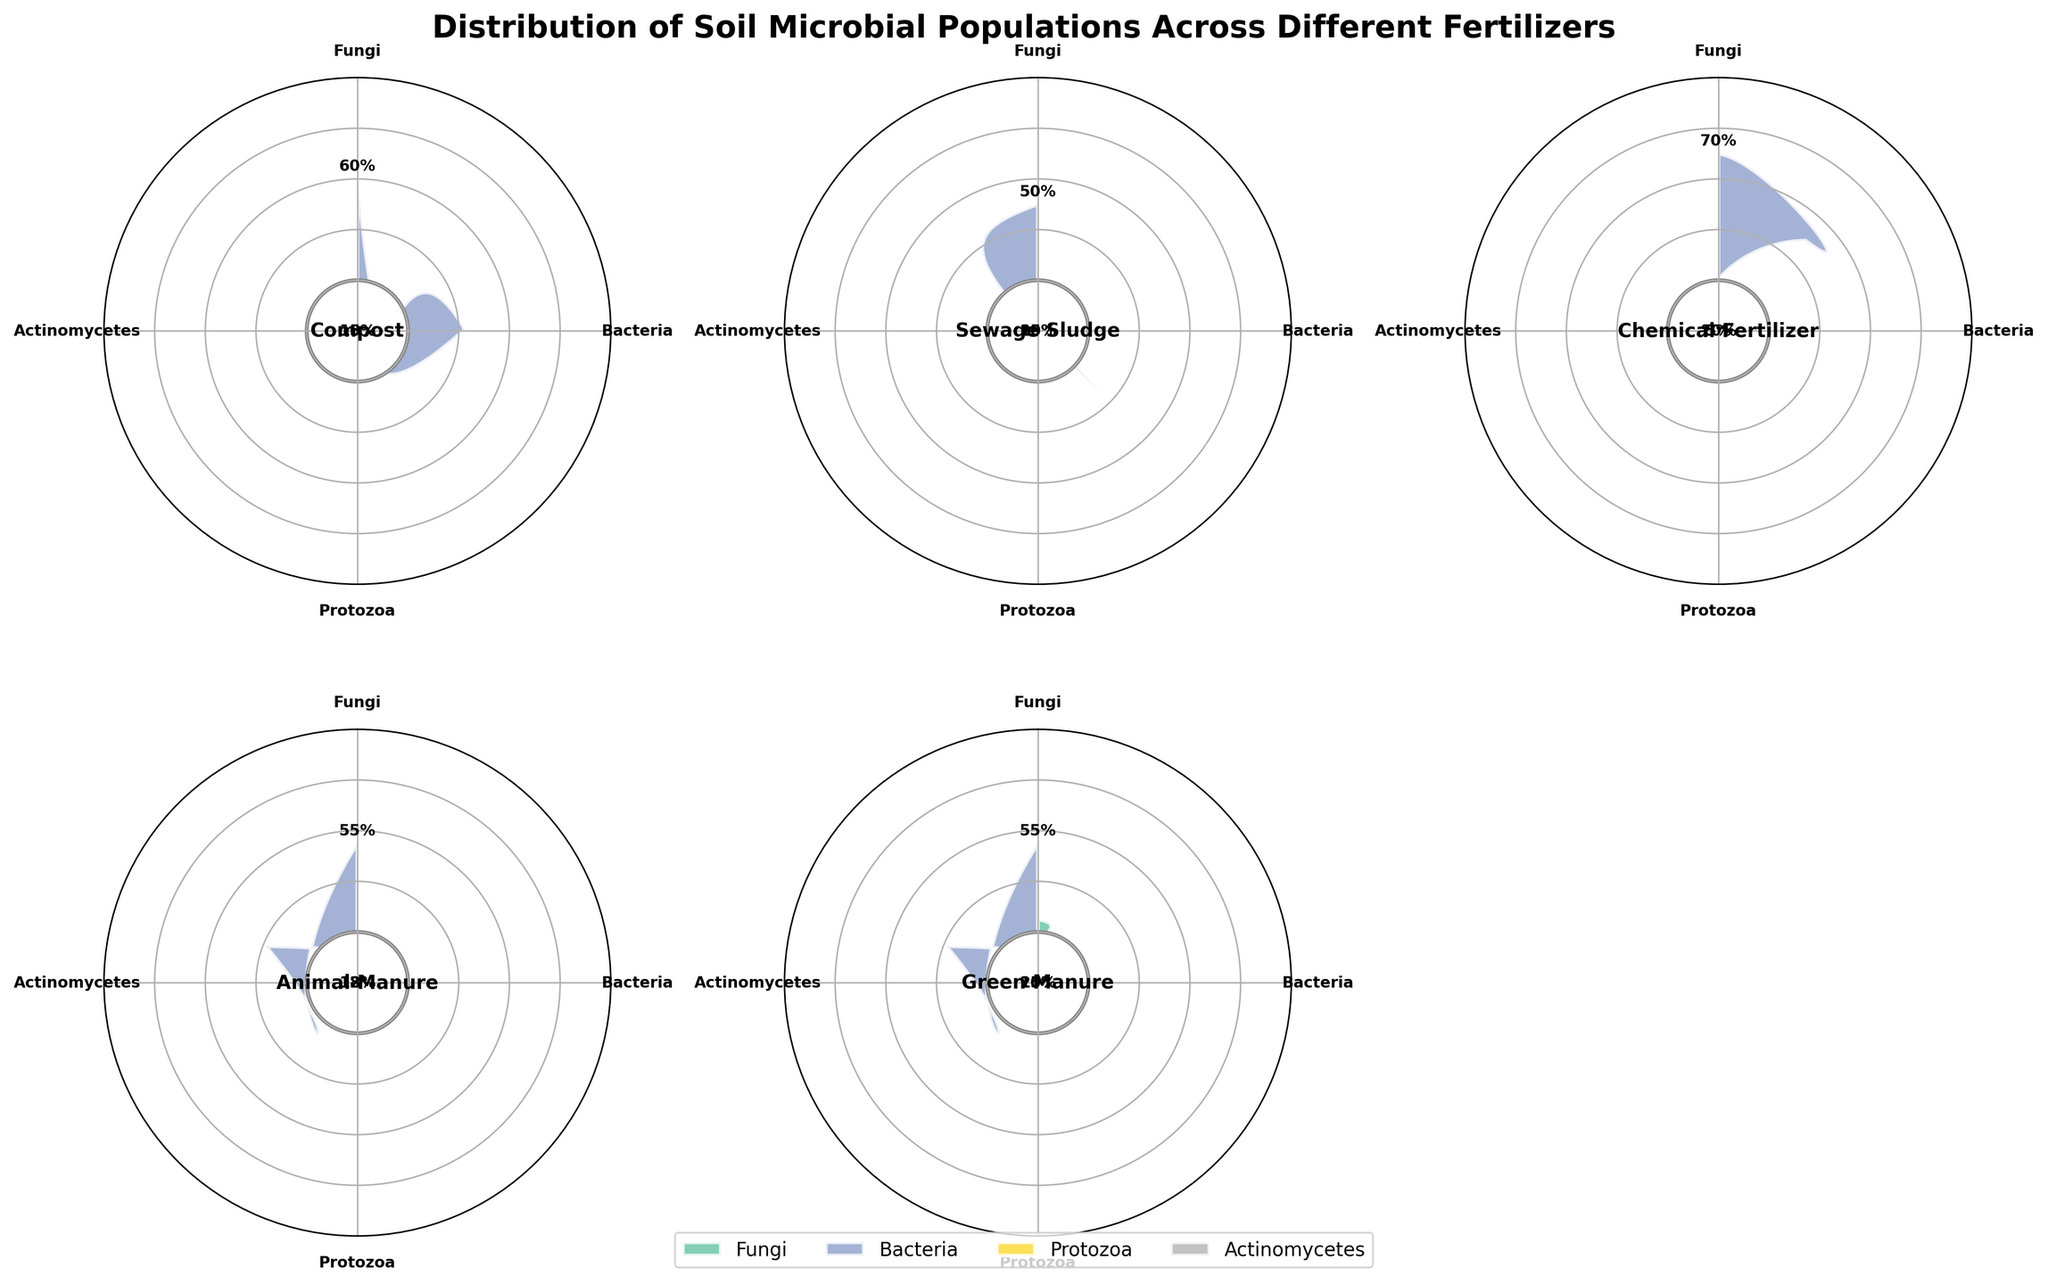Which fertilizer shows the highest percentage of fungi? Find the segment with the largest radial length marked as 'Fungi' by color and inspect the corresponding fertilizer label at the center.
Answer: Green Manure What percentage of bacteria is present in compost? Locate the 'Compost' subplot, identify the wedge colored as 'Bacteria,' and read its percentage label.
Answer: 60% Which two fertilizers have an equal distribution of actinomycetes? Compare the percentages for 'Actinomycetes' across all subplots and see which two fertilizers share the same value.
Answer: Compost and Sewage Sludge What is the average percentage of protozoa across all fertilizers? Add the percentages of protozoa from each subplot (10+15+5+12+10) and divide by the number of fertilizers.
Answer: 10.4% Which fertilizer has the lowest percentage of protozoa? Find the subplot with the smallest radial length for the 'Protozoa' color, then check the corresponding fertilizer label.
Answer: Chemical Fertilizer Is the percentage of bacteria in sewage sludge higher or lower than that in animal manure? Compare the percentage labels for 'Bacteria' in the Sewage Sludge and Animal Manure subplots.
Answer: Lower What percentage of microbial composition does fungi contribute in chemical fertilizer? Locate the 'Chemical Fertilizer' subplot and read the percentage label for the 'Fungi' colored wedge.
Answer: 10% How does the percentage distribution of bacteria compare between Green Manure and Compost? Compare the percentage labels of 'Bacteria' between the subplots of Green Manure and Compost.
Answer: Equal Among Compost, Sewage Sludge, and Animal Manure, which has the most varied microbial composition? Assess the spread and differences in wedge lengths within each subplot, focusing on 'Compost', 'Sewage Sludge', and 'Animal Manure'.
Answer: Animal Manure What is the relative difference in fungi percentage between Green Manure and Compost? Green Manure has 25%, Compost has 15%. Calculate the difference and provide the result.
Answer: 10% 